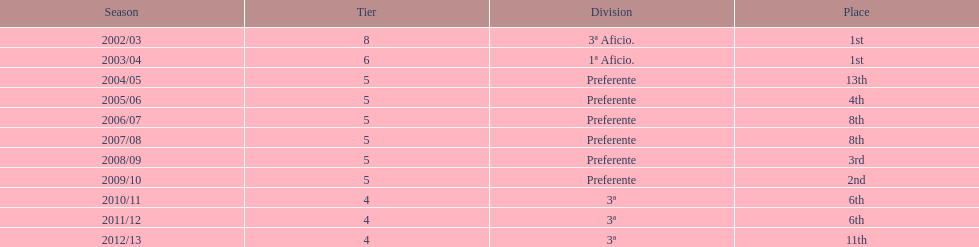For how many years did the team stay in the 3rd division? 4. 